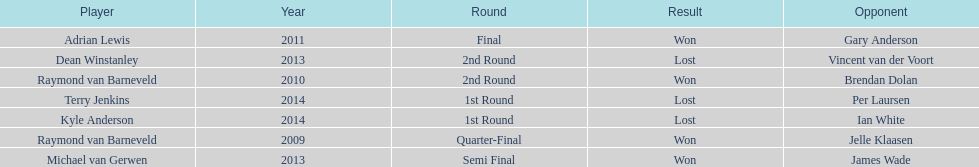How many champions were from norway? 0. 